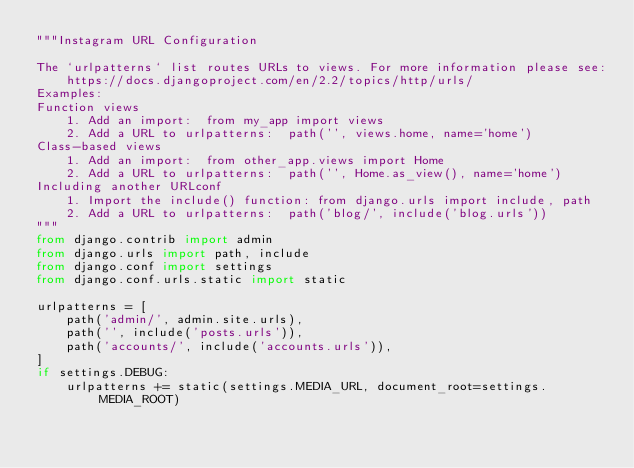Convert code to text. <code><loc_0><loc_0><loc_500><loc_500><_Python_>"""Instagram URL Configuration

The `urlpatterns` list routes URLs to views. For more information please see:
    https://docs.djangoproject.com/en/2.2/topics/http/urls/
Examples:
Function views
    1. Add an import:  from my_app import views
    2. Add a URL to urlpatterns:  path('', views.home, name='home')
Class-based views
    1. Add an import:  from other_app.views import Home
    2. Add a URL to urlpatterns:  path('', Home.as_view(), name='home')
Including another URLconf
    1. Import the include() function: from django.urls import include, path
    2. Add a URL to urlpatterns:  path('blog/', include('blog.urls'))
"""
from django.contrib import admin
from django.urls import path, include
from django.conf import settings
from django.conf.urls.static import static

urlpatterns = [
    path('admin/', admin.site.urls),
    path('', include('posts.urls')),
    path('accounts/', include('accounts.urls')),
]
if settings.DEBUG:
    urlpatterns += static(settings.MEDIA_URL, document_root=settings.MEDIA_ROOT)
</code> 